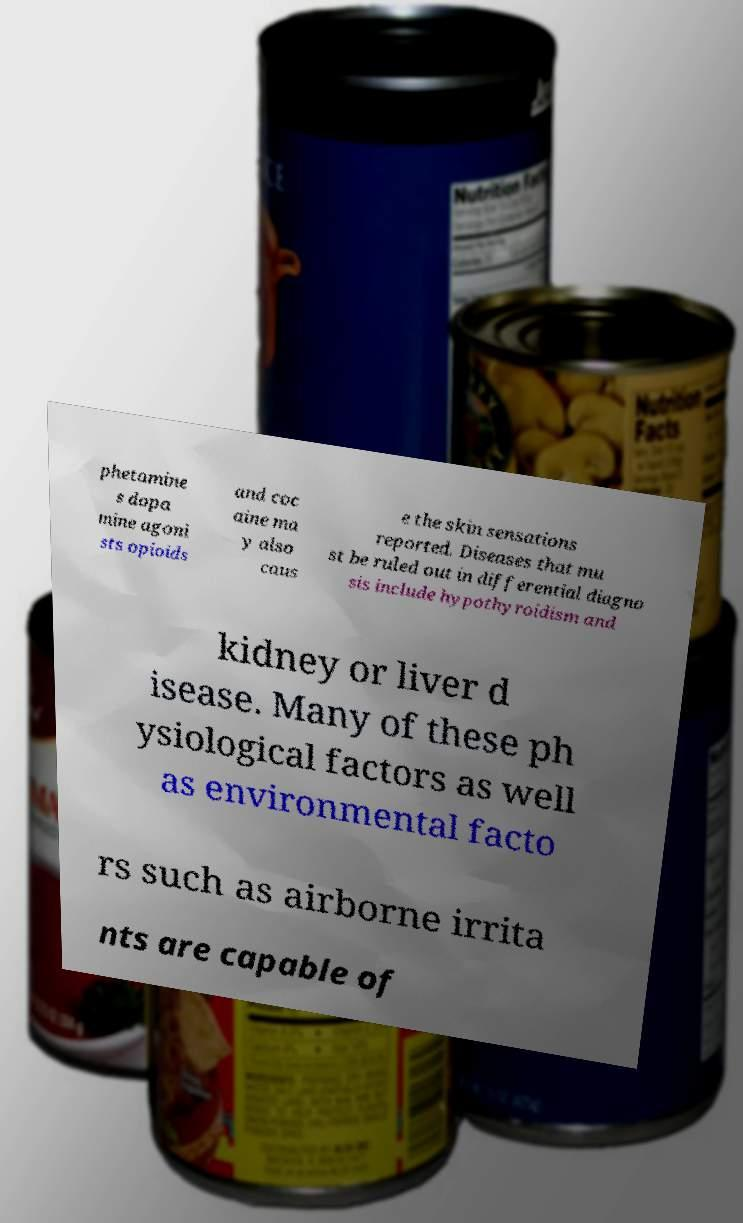What messages or text are displayed in this image? I need them in a readable, typed format. phetamine s dopa mine agoni sts opioids and coc aine ma y also caus e the skin sensations reported. Diseases that mu st be ruled out in differential diagno sis include hypothyroidism and kidney or liver d isease. Many of these ph ysiological factors as well as environmental facto rs such as airborne irrita nts are capable of 